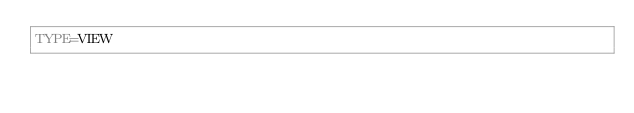Convert code to text. <code><loc_0><loc_0><loc_500><loc_500><_VisualBasic_>TYPE=VIEW</code> 